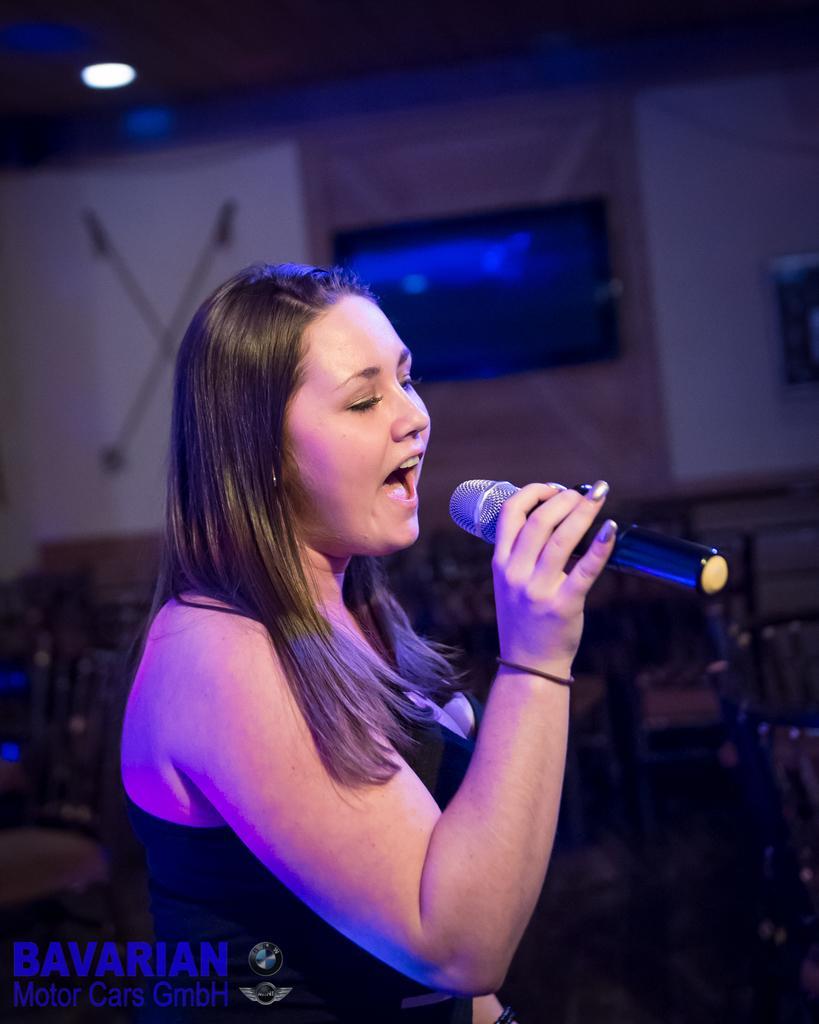Please provide a concise description of this image. This is the woman standing and singing a song. She is holding a mike. In the background, that looks like a frame, which is attached to the wall. At the bottom of the image, I can see the watermark and logo. 